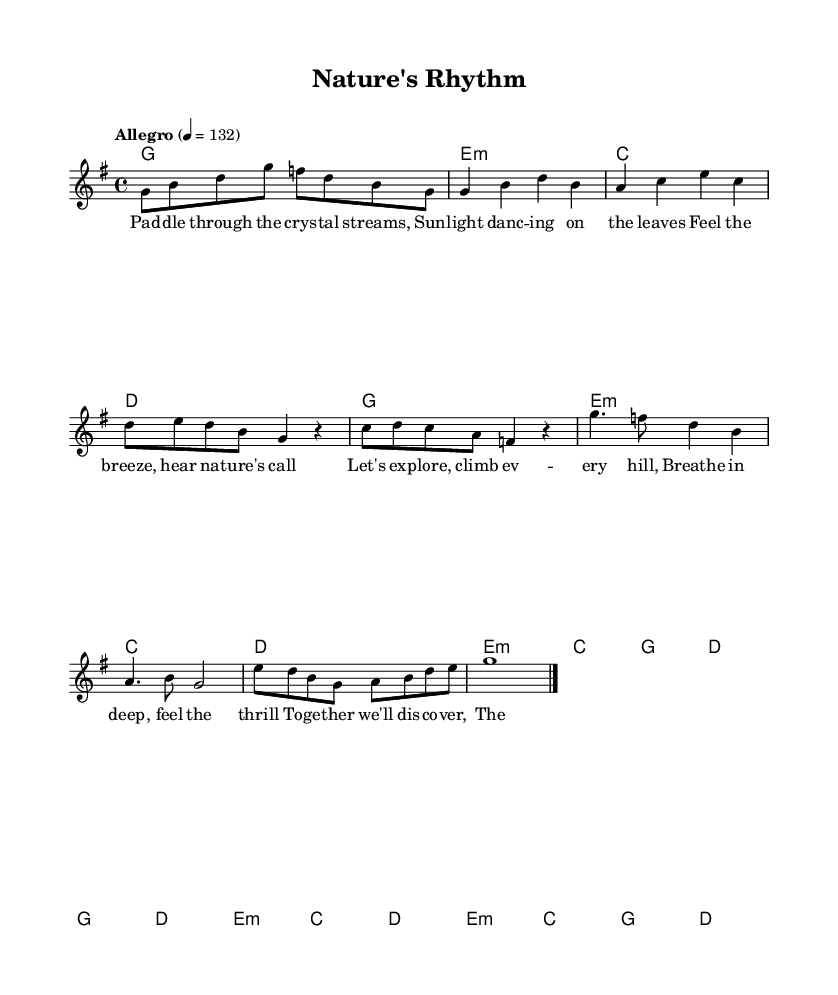What is the key signature of this music? The key signature is G major, which has one sharp, F#. This can be determined from the global settings where the key is specified as G.
Answer: G major What is the time signature of this music? The time signature is 4/4, as indicated in the global settings. This means there are four beats in each measure, and a quarter note receives one beat.
Answer: 4/4 What is the tempo marking of this music? The tempo marking is "Allegro" at a quarter note equals 132 beats per minute, as stated in the global settings. This indicates a fast-paced rhythm.
Answer: Allegro 4 = 132 How many measures are in the Chorus section? The Chorus section consists of 4 measures, as evidenced by the grouping of the melody and chord changes in that section.
Answer: 4 What is the first lyric in the Verse? The first lyric in the Verse is "Paddle", as indicated in the lyric section for the verse. The lyrics are aligned with the melody notes.
Answer: Paddle What instruments are featured in this score? The score features a lead voice and chord names. The lead voice performs the melody, while the chord names indicate the harmonic structure played along with it.
Answer: Lead voice and chord names How does the musical structure of this song align with typical K-Pop forms? The structure follows a common K-Pop format, which typically includes Intro, Verse, Pre-Chorus, Chorus, and Bridge. This organization helps build excitement and engagement throughout the song.
Answer: Verse, Pre-Chorus, Chorus, Bridge 